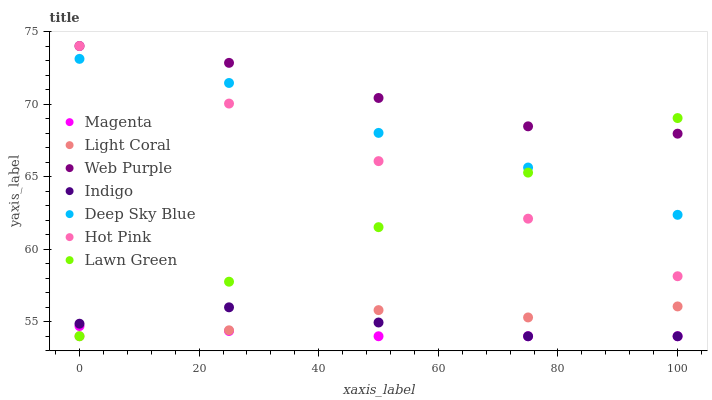Does Magenta have the minimum area under the curve?
Answer yes or no. Yes. Does Web Purple have the maximum area under the curve?
Answer yes or no. Yes. Does Indigo have the minimum area under the curve?
Answer yes or no. No. Does Indigo have the maximum area under the curve?
Answer yes or no. No. Is Lawn Green the smoothest?
Answer yes or no. Yes. Is Light Coral the roughest?
Answer yes or no. Yes. Is Indigo the smoothest?
Answer yes or no. No. Is Indigo the roughest?
Answer yes or no. No. Does Lawn Green have the lowest value?
Answer yes or no. Yes. Does Hot Pink have the lowest value?
Answer yes or no. No. Does Web Purple have the highest value?
Answer yes or no. Yes. Does Indigo have the highest value?
Answer yes or no. No. Is Magenta less than Deep Sky Blue?
Answer yes or no. Yes. Is Hot Pink greater than Magenta?
Answer yes or no. Yes. Does Lawn Green intersect Hot Pink?
Answer yes or no. Yes. Is Lawn Green less than Hot Pink?
Answer yes or no. No. Is Lawn Green greater than Hot Pink?
Answer yes or no. No. Does Magenta intersect Deep Sky Blue?
Answer yes or no. No. 